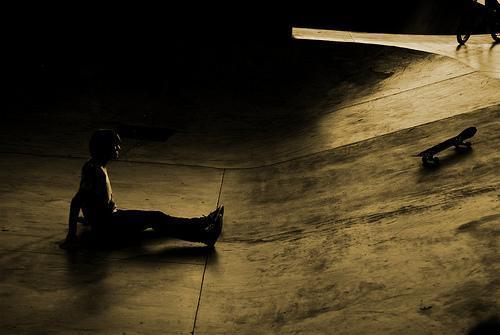How many skateboards are there?
Give a very brief answer. 1. 